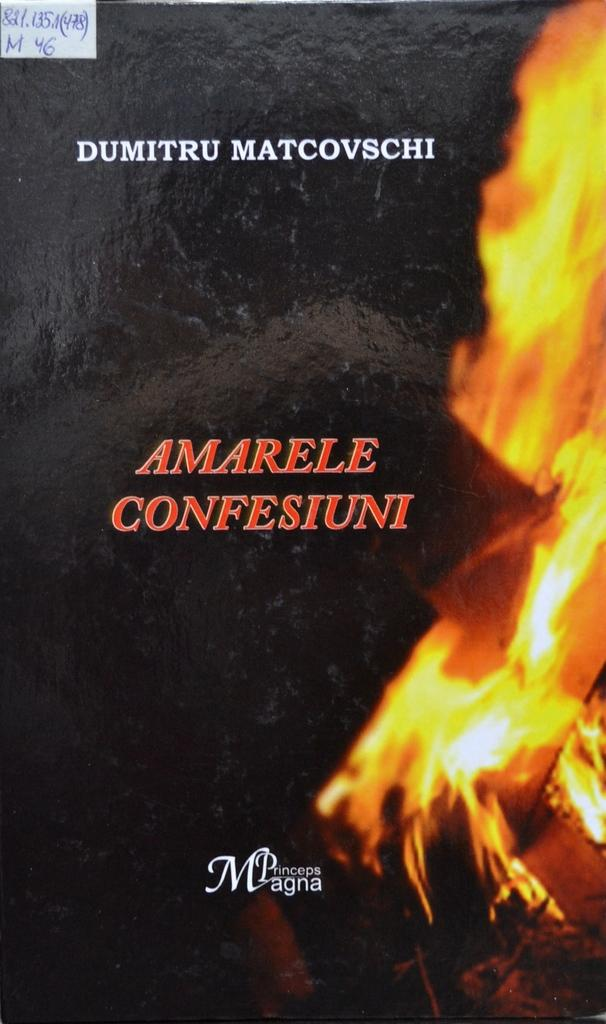<image>
Summarize the visual content of the image. A book called AMARELA CONFESIUNI by DUMITRU MATCOVSCHI. 